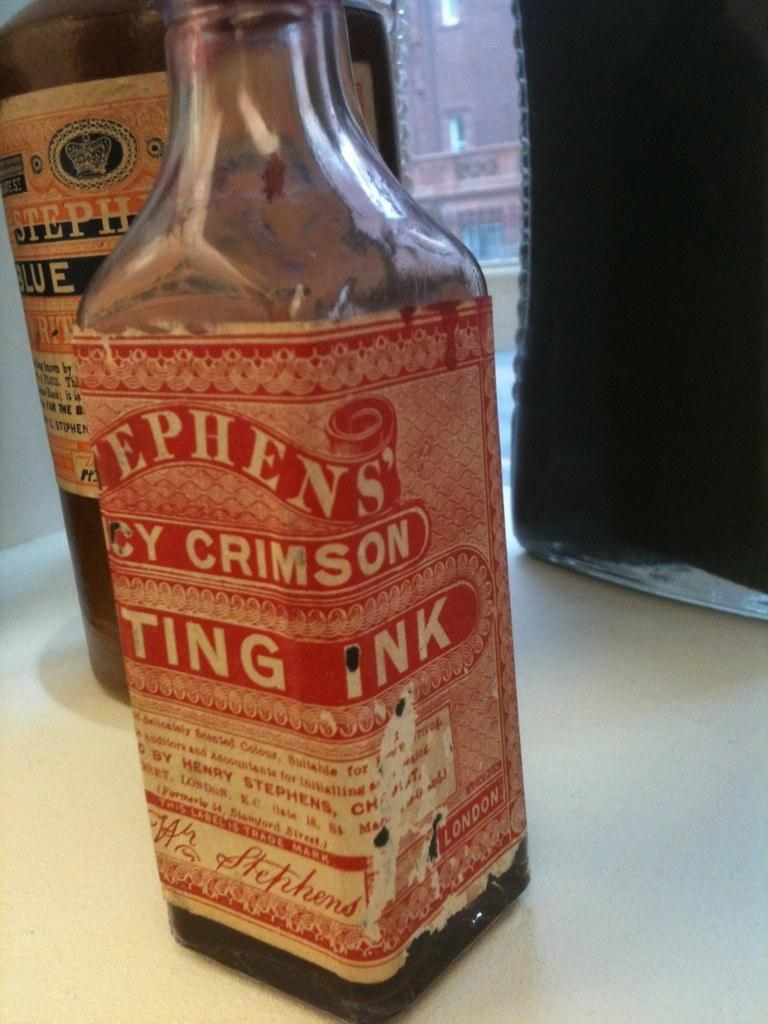<image>
Create a compact narrative representing the image presented. A bottle of printing ink sits on a table. 